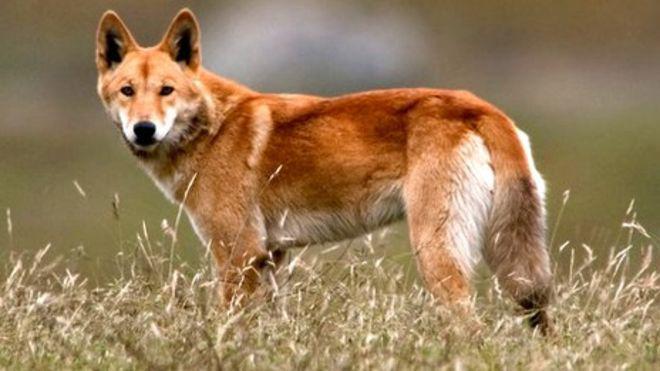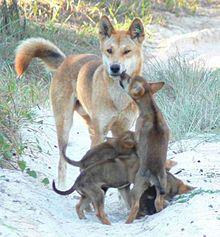The first image is the image on the left, the second image is the image on the right. Given the left and right images, does the statement "There are no more than 2 dogs per image pair" hold true? Answer yes or no. No. 